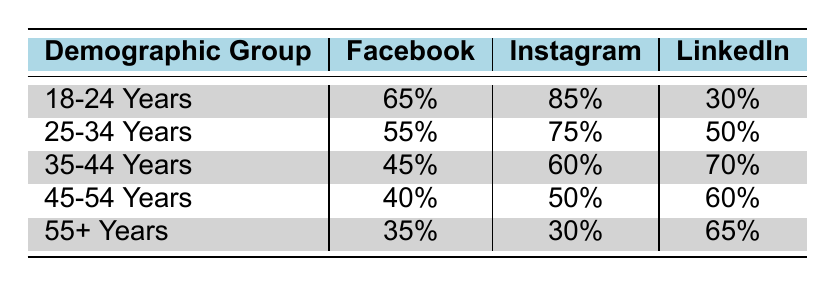What is the engagement percentage for the 18-24 years demographic on Instagram? The table shows the engagement percentage for each demographic group across different platforms. For the 18-24 years demographic, the engagement percentage on Instagram is listed as 85%.
Answer: 85% Which demographic group has the highest engagement on LinkedIn? Looking at the LinkedIn engagement percentages for each demographic group, the 35-44 years demographic has the highest engagement at 70%.
Answer: 35-44 Years What is the average engagement percentage of the 25-34 years demographic across all platforms? To find the average engagement for the 25-34 years demographic, add the engagement values: 55% (Facebook) + 75% (Instagram) + 50% (LinkedIn) = 180%. Then, divide by the number of platforms (3): 180% / 3 = 60%.
Answer: 60% Do more alumni aged 45-54 engage on Facebook than those aged 35-44? The engagement percentage for 45-54 years on Facebook is 40%, while for 35-44 years, it is 45%. Since 40% is less than 45%, the statement is false.
Answer: No What is the total engagement percentage for the 55+ years demographic across all platforms? For the 55+ years demographic, add the engagement percentages from all platforms: 35% (Facebook) + 30% (Instagram) + 65% (LinkedIn) = 130%. Therefore, the total engagement percentage is 130%.
Answer: 130% 